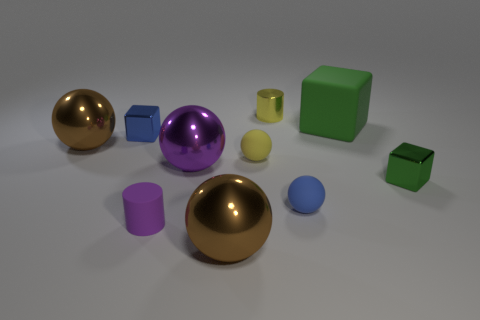There is a small thing that is the same color as the large rubber block; what is its shape?
Your answer should be compact. Cube. Do the tiny blue thing on the left side of the yellow cylinder and the large brown object that is on the left side of the tiny purple matte cylinder have the same shape?
Your answer should be compact. No. How many small objects are brown rubber cylinders or spheres?
Ensure brevity in your answer.  2. There is a tiny yellow object that is the same material as the large block; what is its shape?
Keep it short and to the point. Sphere. Does the purple matte thing have the same shape as the tiny yellow shiny thing?
Ensure brevity in your answer.  Yes. What color is the big matte object?
Keep it short and to the point. Green. What number of objects are big purple cylinders or tiny matte things?
Your answer should be very brief. 3. Are there any other things that are the same material as the small green thing?
Your answer should be very brief. Yes. Are there fewer big brown things on the right side of the tiny green shiny thing than big red cylinders?
Ensure brevity in your answer.  No. Is the number of big rubber cubes that are to the left of the large green rubber thing greater than the number of blocks on the right side of the tiny blue matte sphere?
Your answer should be compact. No. 